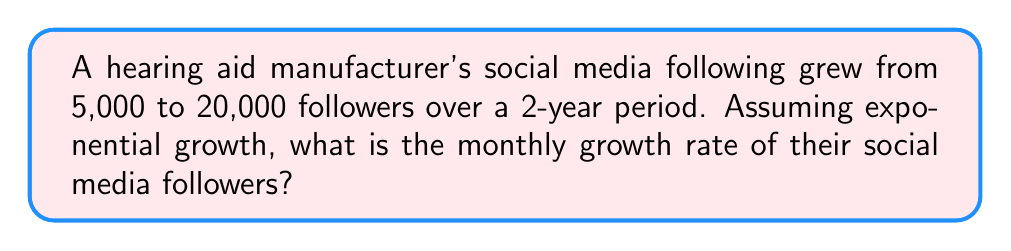Provide a solution to this math problem. Let's approach this step-by-step:

1) The exponential growth formula is:
   $A = P(1 + r)^t$
   Where:
   $A$ = final amount
   $P$ = initial amount
   $r$ = growth rate (per unit of time)
   $t$ = time

2) We know:
   $P = 5,000$
   $A = 20,000$
   $t = 24$ months (2 years)

3) Substituting these values:
   $20,000 = 5,000(1 + r)^{24}$

4) Divide both sides by 5,000:
   $4 = (1 + r)^{24}$

5) Take the 24th root of both sides:
   $\sqrt[24]{4} = 1 + r$

6) Subtract 1 from both sides:
   $\sqrt[24]{4} - 1 = r$

7) Calculate:
   $r = \sqrt[24]{4} - 1 \approx 0.0582 \approx 5.82\%$

This represents the monthly growth rate.
Answer: 5.82% 